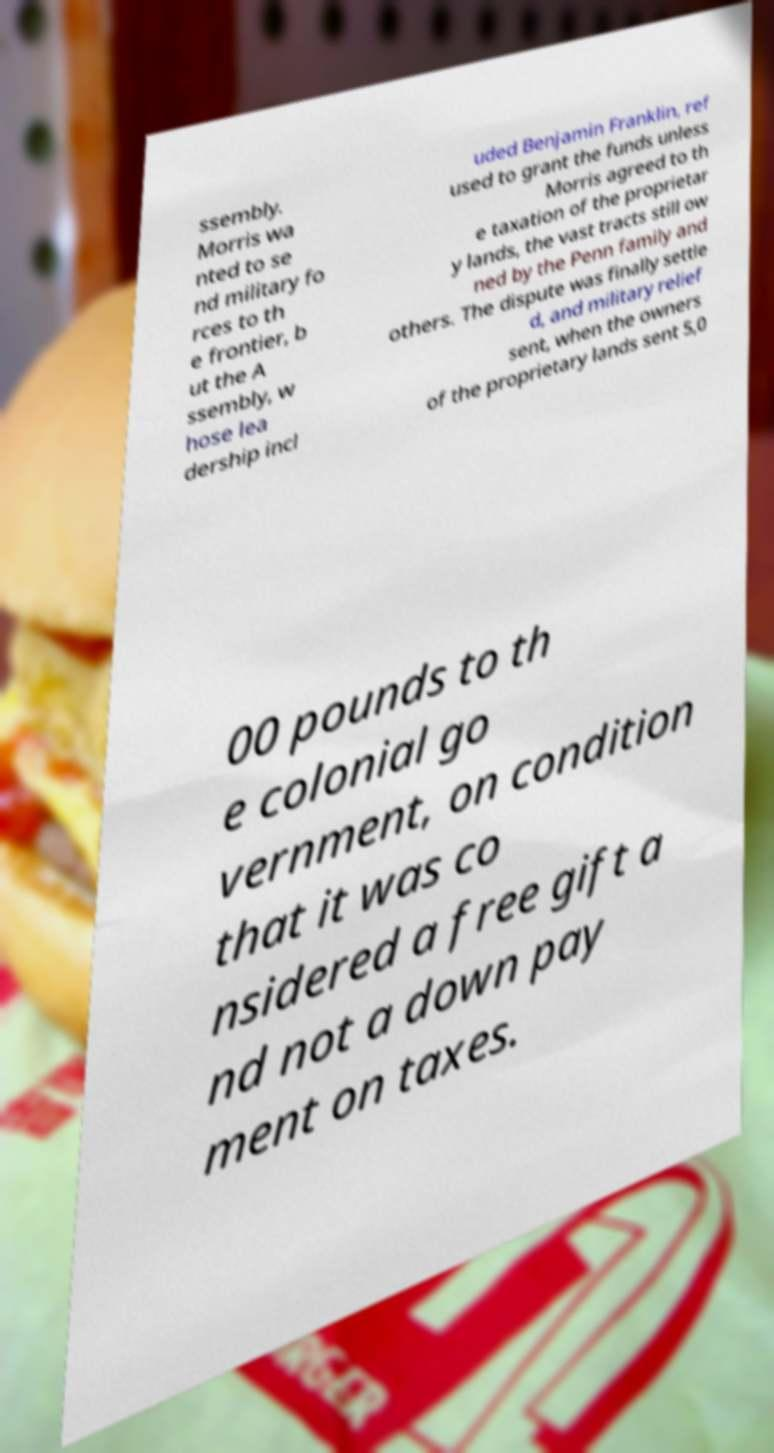Can you read and provide the text displayed in the image?This photo seems to have some interesting text. Can you extract and type it out for me? ssembly. Morris wa nted to se nd military fo rces to th e frontier, b ut the A ssembly, w hose lea dership incl uded Benjamin Franklin, ref used to grant the funds unless Morris agreed to th e taxation of the proprietar y lands, the vast tracts still ow ned by the Penn family and others. The dispute was finally settle d, and military relief sent, when the owners of the proprietary lands sent 5,0 00 pounds to th e colonial go vernment, on condition that it was co nsidered a free gift a nd not a down pay ment on taxes. 